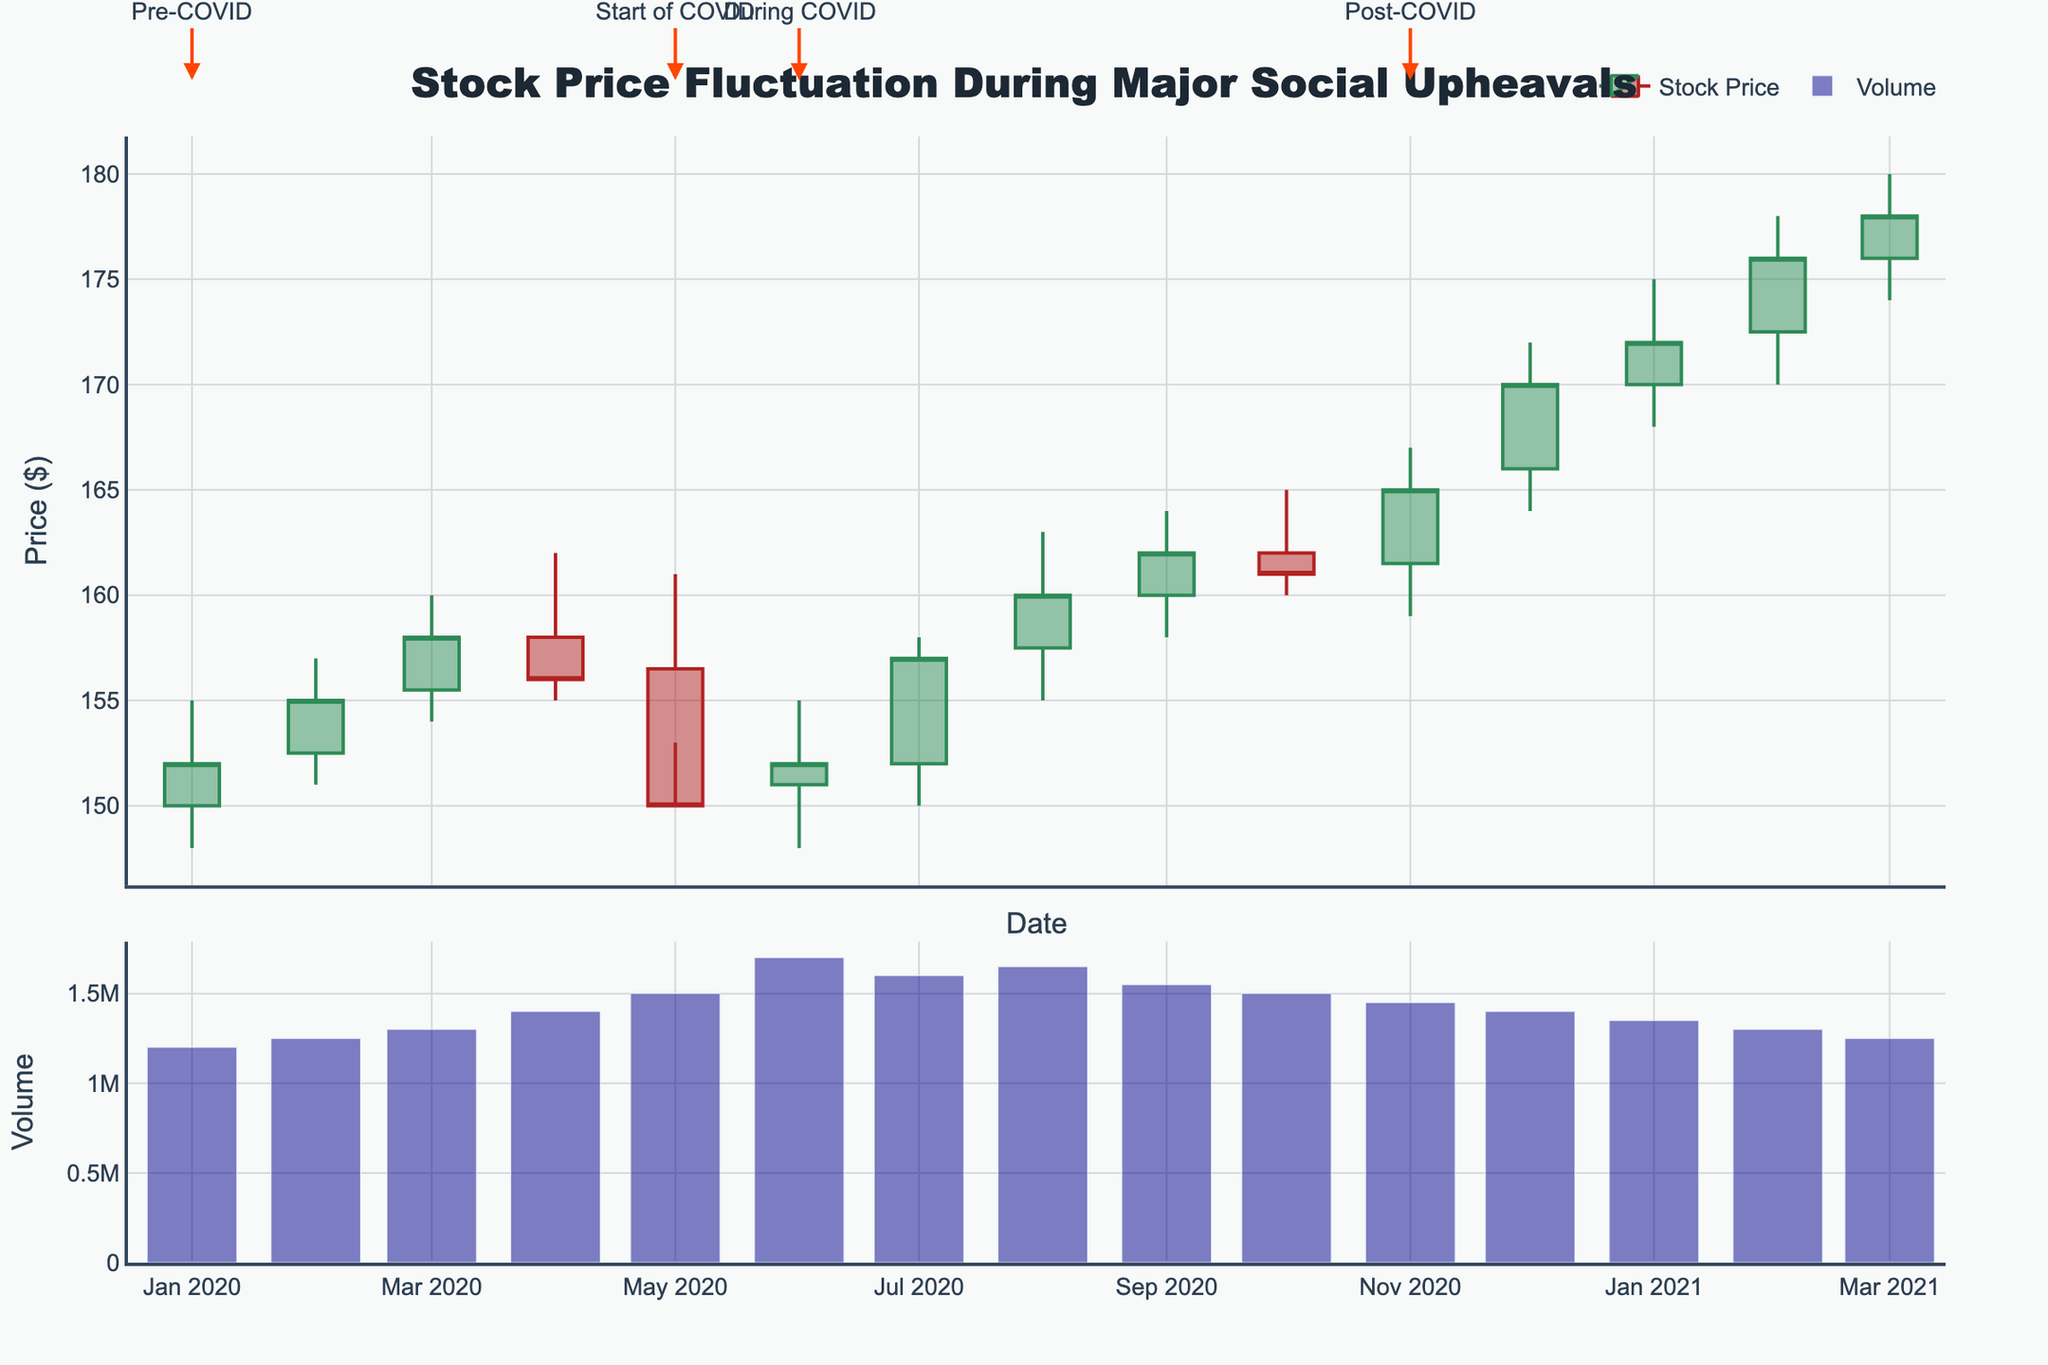What is the title of the plot? The title of the plot is located at the top of the figure. It reads "Stock Price Fluctuation During Major Social Upheavals."
Answer: Stock Price Fluctuation During Major Social Upheavals What is the color of the increasing price lines? The color of the increasing price lines in the candlestick plot is represented using dark green lines.
Answer: Dark green What is the highest closing price after the "Start of COVID" event? After the "Start of COVID" event in May 2020, the highest closing price can be identified by looking at the candlestick bars, focusing on the highest point of the closing prices in subsequent months. The highest closing price is in March 2021 with a closing price of 178.0.
Answer: 178.0 How does the trading volume change from April 2020 to May 2020? To find the change in trading volume from April 2020 to May 2020, compare the bar heights in the volume subplot for these two months. In April 2020, the volume is 1,400,000, and in May 2020, it is 1,500,000. The volume increased by 100,000.
Answer: Increased by 100,000 Which month had the largest drop in the closing price during the "Pre-COVID" period? During the "Pre-COVID" period, compare the closing prices of each month. April 2020 had a closing price of 156.0, and May 2020 had a closing price of 150.0, which indicates the largest drop.
Answer: May 2020 What is the trend in stock prices from the "Start of COVID" to "During COVID"? Visualize the candlestick bars from May 2020 ("Start of COVID") through October 2020 ("During COVID"). The trend shows a gradual increase in stock prices over these months. Initially, there's a small drop, and then a subsequent rise for the rest of the period.
Answer: Gradual increase How did the trading volume change in the month of June 2020? Examine the height of the volume bar for June 2020, which indicates an increase when compared to the previous month, May 2020. In June 2020, the volume was 1,700,000 compared to 1,500,000 in May 2020.
Answer: Increased What is the color of the bars indicating trading volume? The bars indicating trading volume are colored in dark blue with some transparency, which allows us to distinguish them from the candlestick plot.
Answer: Dark blue Which month shows the highest trading volume and what is the value? To determine the month with the highest trading volume, look at the tallest bar in the volume subplot. The month with the highest volume is June 2020, with a value of 1,700,000.
Answer: June 2020, 1,700,000 What event is indicated near the highest closing stock price on the candlestick chart? Near the highest closing stock price in March 2021 (178.0), the event indicated by an annotation is "Post-COVID."
Answer: Post-COVID 